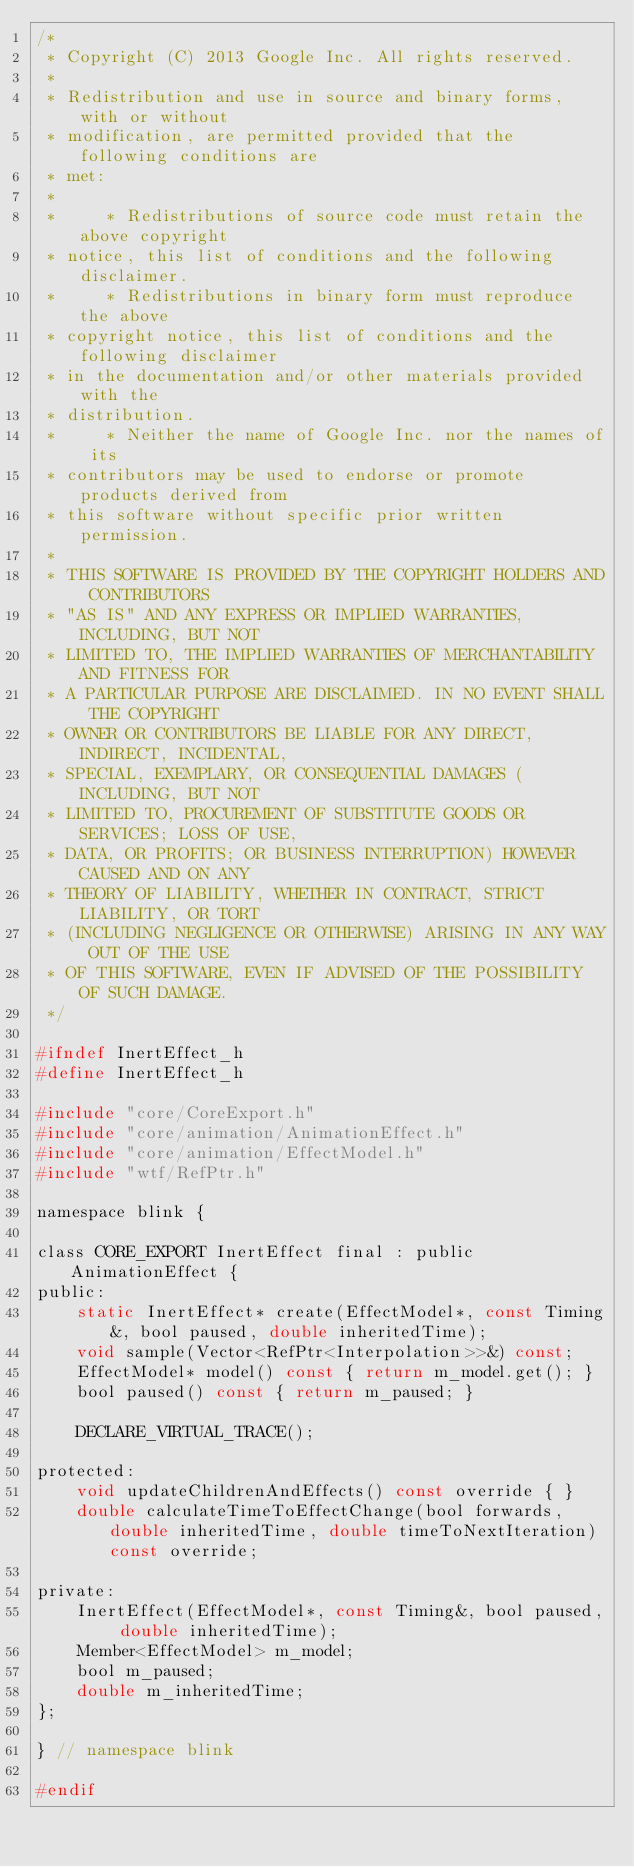<code> <loc_0><loc_0><loc_500><loc_500><_C_>/*
 * Copyright (C) 2013 Google Inc. All rights reserved.
 *
 * Redistribution and use in source and binary forms, with or without
 * modification, are permitted provided that the following conditions are
 * met:
 *
 *     * Redistributions of source code must retain the above copyright
 * notice, this list of conditions and the following disclaimer.
 *     * Redistributions in binary form must reproduce the above
 * copyright notice, this list of conditions and the following disclaimer
 * in the documentation and/or other materials provided with the
 * distribution.
 *     * Neither the name of Google Inc. nor the names of its
 * contributors may be used to endorse or promote products derived from
 * this software without specific prior written permission.
 *
 * THIS SOFTWARE IS PROVIDED BY THE COPYRIGHT HOLDERS AND CONTRIBUTORS
 * "AS IS" AND ANY EXPRESS OR IMPLIED WARRANTIES, INCLUDING, BUT NOT
 * LIMITED TO, THE IMPLIED WARRANTIES OF MERCHANTABILITY AND FITNESS FOR
 * A PARTICULAR PURPOSE ARE DISCLAIMED. IN NO EVENT SHALL THE COPYRIGHT
 * OWNER OR CONTRIBUTORS BE LIABLE FOR ANY DIRECT, INDIRECT, INCIDENTAL,
 * SPECIAL, EXEMPLARY, OR CONSEQUENTIAL DAMAGES (INCLUDING, BUT NOT
 * LIMITED TO, PROCUREMENT OF SUBSTITUTE GOODS OR SERVICES; LOSS OF USE,
 * DATA, OR PROFITS; OR BUSINESS INTERRUPTION) HOWEVER CAUSED AND ON ANY
 * THEORY OF LIABILITY, WHETHER IN CONTRACT, STRICT LIABILITY, OR TORT
 * (INCLUDING NEGLIGENCE OR OTHERWISE) ARISING IN ANY WAY OUT OF THE USE
 * OF THIS SOFTWARE, EVEN IF ADVISED OF THE POSSIBILITY OF SUCH DAMAGE.
 */

#ifndef InertEffect_h
#define InertEffect_h

#include "core/CoreExport.h"
#include "core/animation/AnimationEffect.h"
#include "core/animation/EffectModel.h"
#include "wtf/RefPtr.h"

namespace blink {

class CORE_EXPORT InertEffect final : public AnimationEffect {
public:
    static InertEffect* create(EffectModel*, const Timing&, bool paused, double inheritedTime);
    void sample(Vector<RefPtr<Interpolation>>&) const;
    EffectModel* model() const { return m_model.get(); }
    bool paused() const { return m_paused; }

    DECLARE_VIRTUAL_TRACE();

protected:
    void updateChildrenAndEffects() const override { }
    double calculateTimeToEffectChange(bool forwards, double inheritedTime, double timeToNextIteration) const override;

private:
    InertEffect(EffectModel*, const Timing&, bool paused, double inheritedTime);
    Member<EffectModel> m_model;
    bool m_paused;
    double m_inheritedTime;
};

} // namespace blink

#endif
</code> 